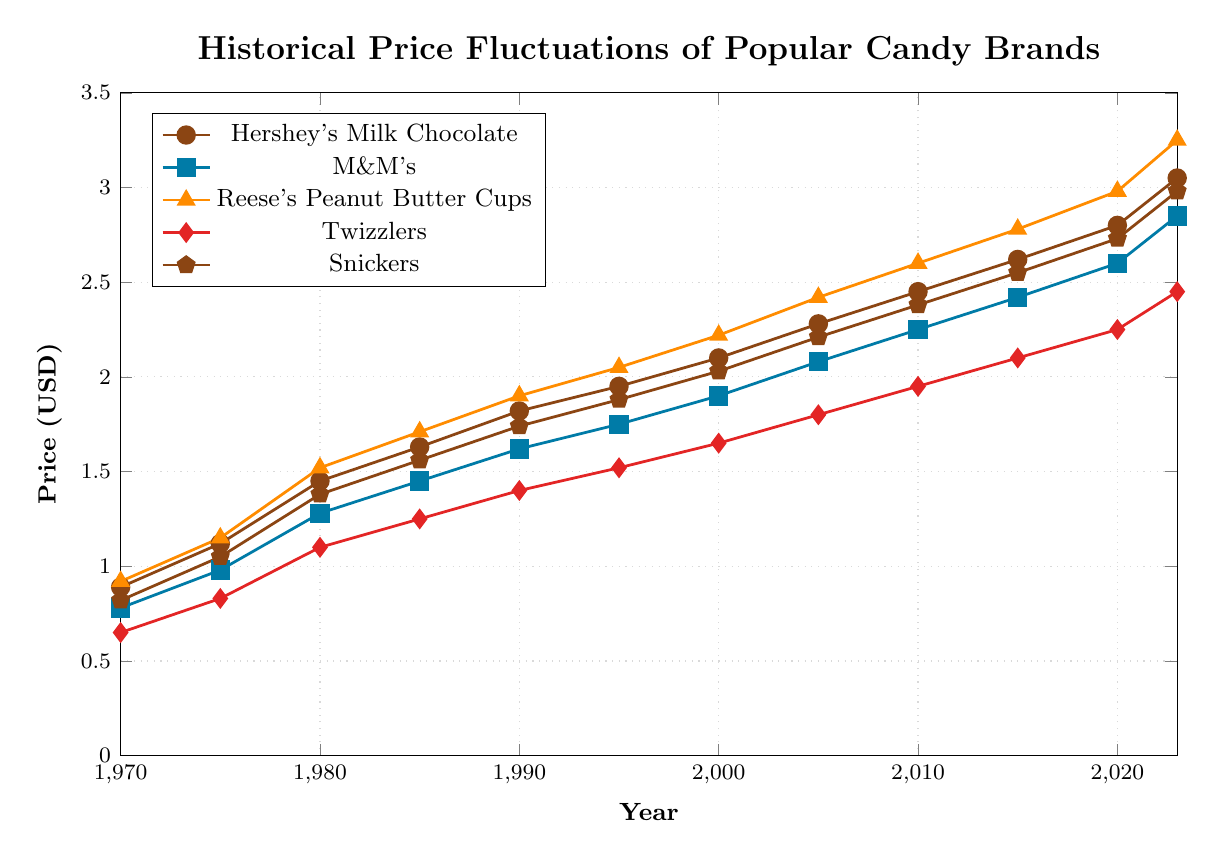Which candy brand had the highest price in 2023? Hershey's Milk Chocolate is represented by circles, and its price in 2023 is the highest at $3.05. Compare the end points of all lines visually, Hershey's Milk Chocolate reaches the highest point.
Answer: Hershey's Milk Chocolate What was the price of Twizzlers in 1995, and how much did it increase by 2023? Find Twizzlers' price in 1995 (marked by diamonds) which is $1.52. In 2023, it is $2.45. The increase is $2.45 - $1.52 = $0.93.
Answer: $0.93 Which candy brand had the smallest price increase from 1970 to 2023? Calculate the difference from 1970 to 2023 for each brand. Hershey's: $3.05 - $0.89 = $2.16; M&M's: $2.85 - $0.78 = $2.07; Reese's: $3.25 - $0.92 = $2.33; Twizzlers: $2.45 - $0.65 = $1.80; Snickers: $2.98 - $0.82 = $2.16. Twizzlers had the smallest increase.
Answer: Twizzlers Between 2000 and 2010, which candy's price grew the fastest? Calculate the growth rate for each brand between 2000 and 2010. Hershey's: $2.45 - $2.10 = $0.35; M&M's: $2.25 - $1.90 = $0.35; Reese's: $2.60 - $2.22 = $0.38; Twizzlers: $1.95 - $1.65 = $0.30; Snickers: $2.38 - $2.03 = $0.35. Reese's had the highest growth.
Answer: Reese's Peanut Butter Cups Describe the overall trend for Snickers from 1970 to 2023. Snickers (pentagon markers) shows a steady increase in price from $0.82 in 1970 to $2.98 in 2023. There are no significant drops or spikes, indicating a consistent upward trend.
Answer: Steady increase Which candy had the closest price to $2.00 in the year 2000? Evaluate the prices in 2000: Hershey's Milk Chocolate $2.10, M&M's $1.90, Reese's $2.22, Twizzlers $1.65, Snickers $2.03. M&M's was the closest to $2.00.
Answer: M&M's By how much did the price of Hershey's Milk Chocolate increase between 1970 and 1980? Hershey's price in 1970 is $0.89 and in 1980 is $1.45. The increase is $1.45 - $0.89 = $0.56.
Answer: $0.56 From 1985 to 2000, which candy brand experienced the largest relative price increase? Calculate relative increases: Hershey's: ($2.10 - $1.63)/$1.63 ≈ 0.29; M&M's: ($1.90 - $1.45)/$1.45 ≈ 0.31; Reese's: ($2.22 - $1.71)/$1.71 ≈ 0.30; Twizzlers: ($1.65 - $1.25)/$1.25 ≈ 0.32; Snickers: ($2.03 - $1.56)/$1.56 ≈ 0.30. Twizzlers had the highest relative increase.
Answer: Twizzlers 